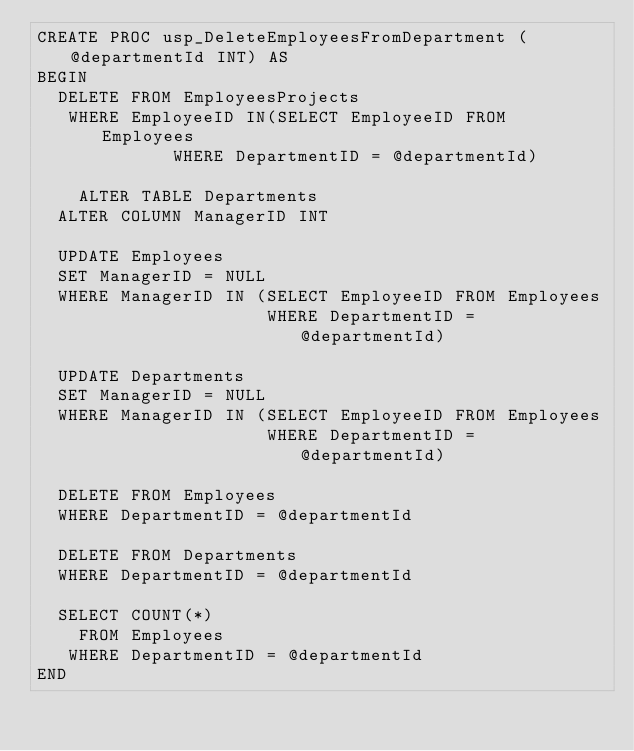<code> <loc_0><loc_0><loc_500><loc_500><_SQL_>CREATE PROC usp_DeleteEmployeesFromDepartment (@departmentId INT) AS
BEGIN
	DELETE FROM EmployeesProjects
	 WHERE EmployeeID IN(SELECT EmployeeID FROM Employees 
						 WHERE DepartmentID = @departmentId) 

    ALTER TABLE Departments
	ALTER COLUMN ManagerID INT

	UPDATE Employees 
	SET ManagerID = NULL
	WHERE ManagerID IN (SELECT EmployeeID FROM Employees
	                    WHERE DepartmentID = @departmentId)

	UPDATE Departments 
	SET ManagerID = NULL
	WHERE ManagerID IN (SELECT EmployeeID FROM Employees
	                    WHERE DepartmentID = @departmentId)

	DELETE FROM Employees
	WHERE DepartmentID = @departmentId
	
	DELETE FROM Departments
	WHERE DepartmentID = @departmentId		
	
	SELECT COUNT(*) 
	  FROM Employees
	 WHERE DepartmentID = @departmentId   		
END

</code> 